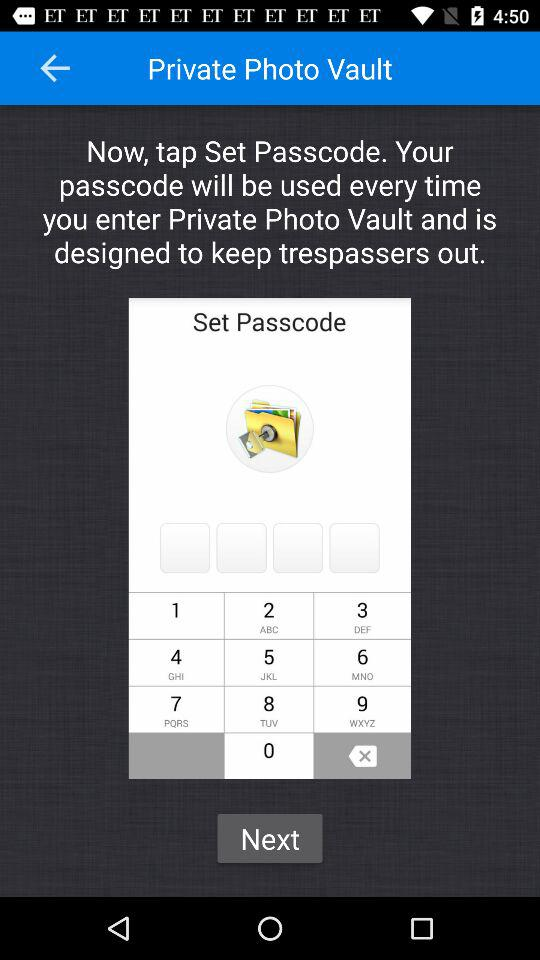What will be used when we enter the "Private Photo Vault"? You will use the passcode to enter the "Private Photo Vault". 